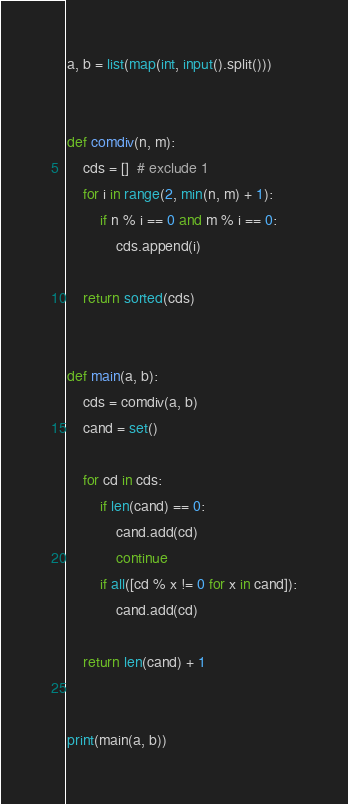<code> <loc_0><loc_0><loc_500><loc_500><_Python_>a, b = list(map(int, input().split()))


def comdiv(n, m):
    cds = []  # exclude 1
    for i in range(2, min(n, m) + 1):
        if n % i == 0 and m % i == 0:
            cds.append(i)

    return sorted(cds)


def main(a, b):
    cds = comdiv(a, b)
    cand = set()

    for cd in cds:
        if len(cand) == 0:
            cand.add(cd)
            continue
        if all([cd % x != 0 for x in cand]):
            cand.add(cd)

    return len(cand) + 1


print(main(a, b))</code> 